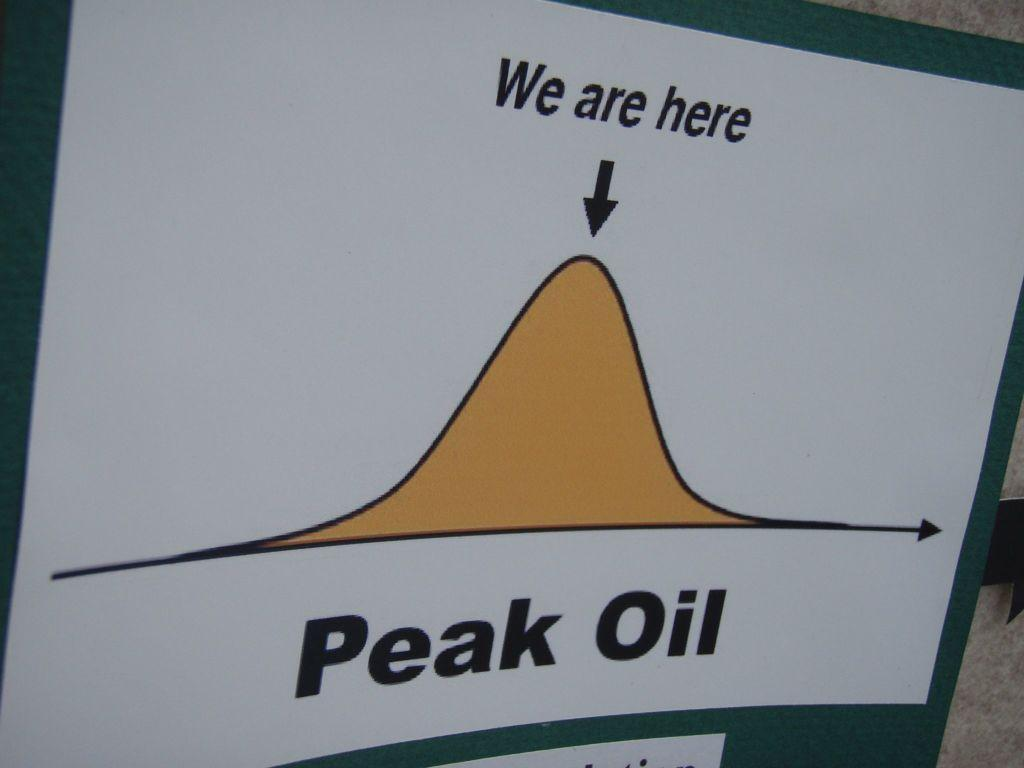<image>
Describe the image concisely. A map telling you that you are on the top of Peak Oil. 